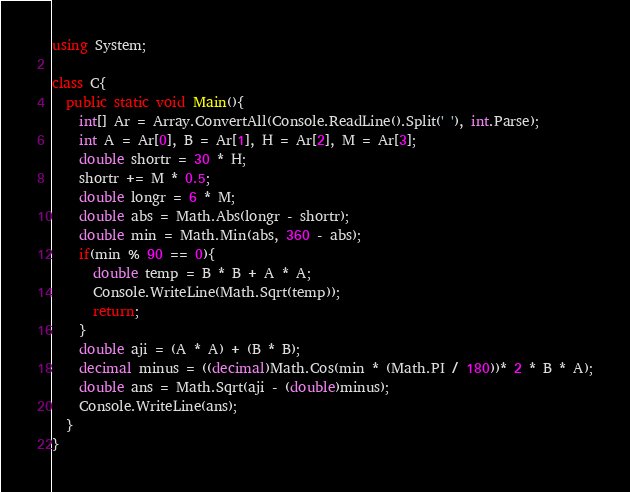<code> <loc_0><loc_0><loc_500><loc_500><_C#_>using System;

class C{
  public static void Main(){
	int[] Ar = Array.ConvertAll(Console.ReadLine().Split(' '), int.Parse);
    int A = Ar[0], B = Ar[1], H = Ar[2], M = Ar[3];
    double shortr = 30 * H;
    shortr += M * 0.5;
    double longr = 6 * M;
    double abs = Math.Abs(longr - shortr);
    double min = Math.Min(abs, 360 - abs);
    if(min % 90 == 0){
      double temp = B * B + A * A;
      Console.WriteLine(Math.Sqrt(temp));
      return;
    }
    double aji = (A * A) + (B * B);
    decimal minus = ((decimal)Math.Cos(min * (Math.PI / 180))* 2 * B * A);
    double ans = Math.Sqrt(aji - (double)minus);
    Console.WriteLine(ans);
  }
}
</code> 